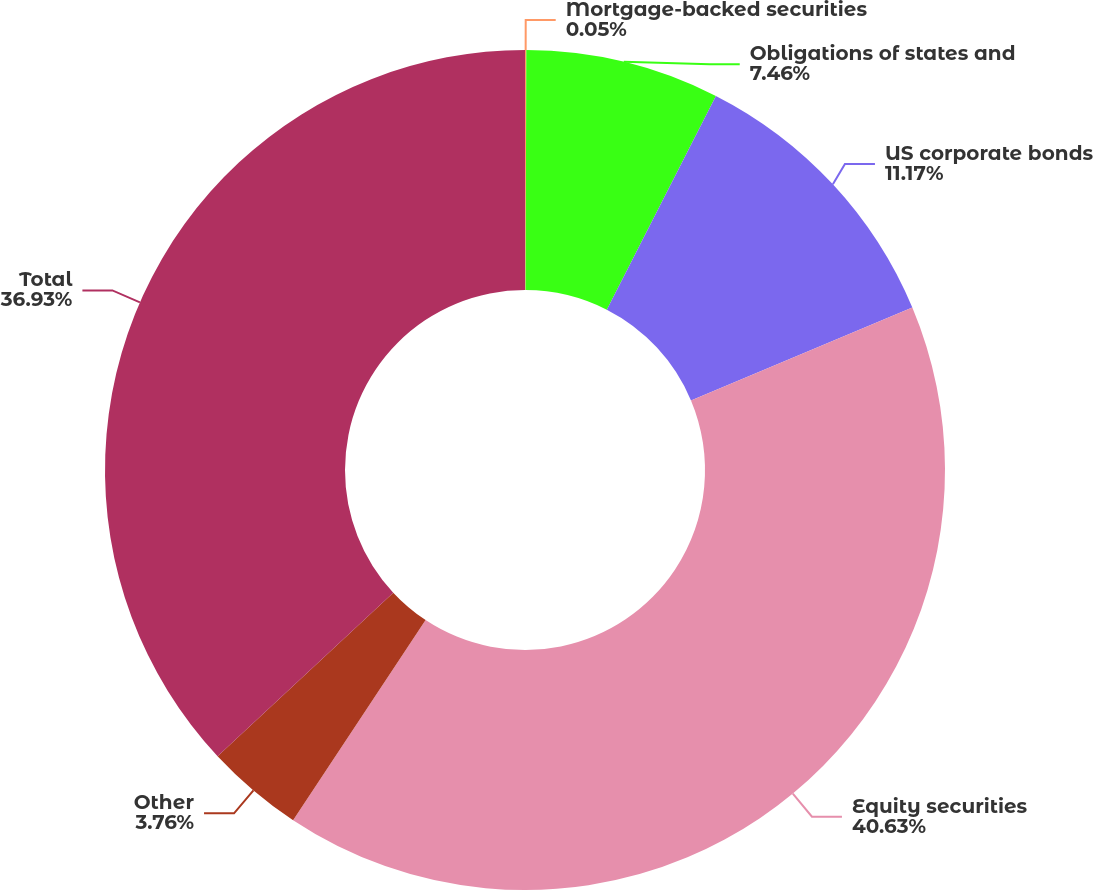<chart> <loc_0><loc_0><loc_500><loc_500><pie_chart><fcel>Mortgage-backed securities<fcel>Obligations of states and<fcel>US corporate bonds<fcel>Equity securities<fcel>Other<fcel>Total<nl><fcel>0.05%<fcel>7.46%<fcel>11.17%<fcel>40.63%<fcel>3.76%<fcel>36.93%<nl></chart> 